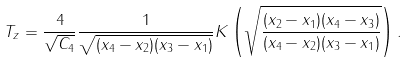Convert formula to latex. <formula><loc_0><loc_0><loc_500><loc_500>T _ { z } = \frac { 4 } { \sqrt { C _ { 4 } } } \frac { 1 } { \sqrt { ( x _ { 4 } - x _ { 2 } ) ( x _ { 3 } - x _ { 1 } ) } } K \left ( \sqrt { \frac { ( x _ { 2 } - x _ { 1 } ) ( x _ { 4 } - x _ { 3 } ) } { ( x _ { 4 } - x _ { 2 } ) ( x _ { 3 } - x _ { 1 } ) } } \right ) .</formula> 